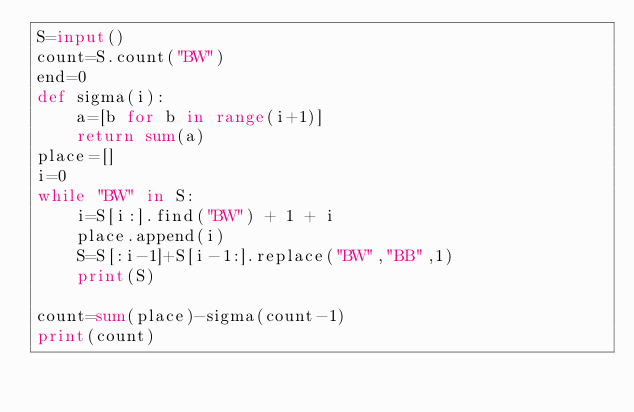<code> <loc_0><loc_0><loc_500><loc_500><_Python_>S=input()
count=S.count("BW")
end=0
def sigma(i):
    a=[b for b in range(i+1)]
    return sum(a)
place=[]
i=0
while "BW" in S:
    i=S[i:].find("BW") + 1 + i
    place.append(i)
    S=S[:i-1]+S[i-1:].replace("BW","BB",1)
    print(S)

count=sum(place)-sigma(count-1)
print(count)</code> 